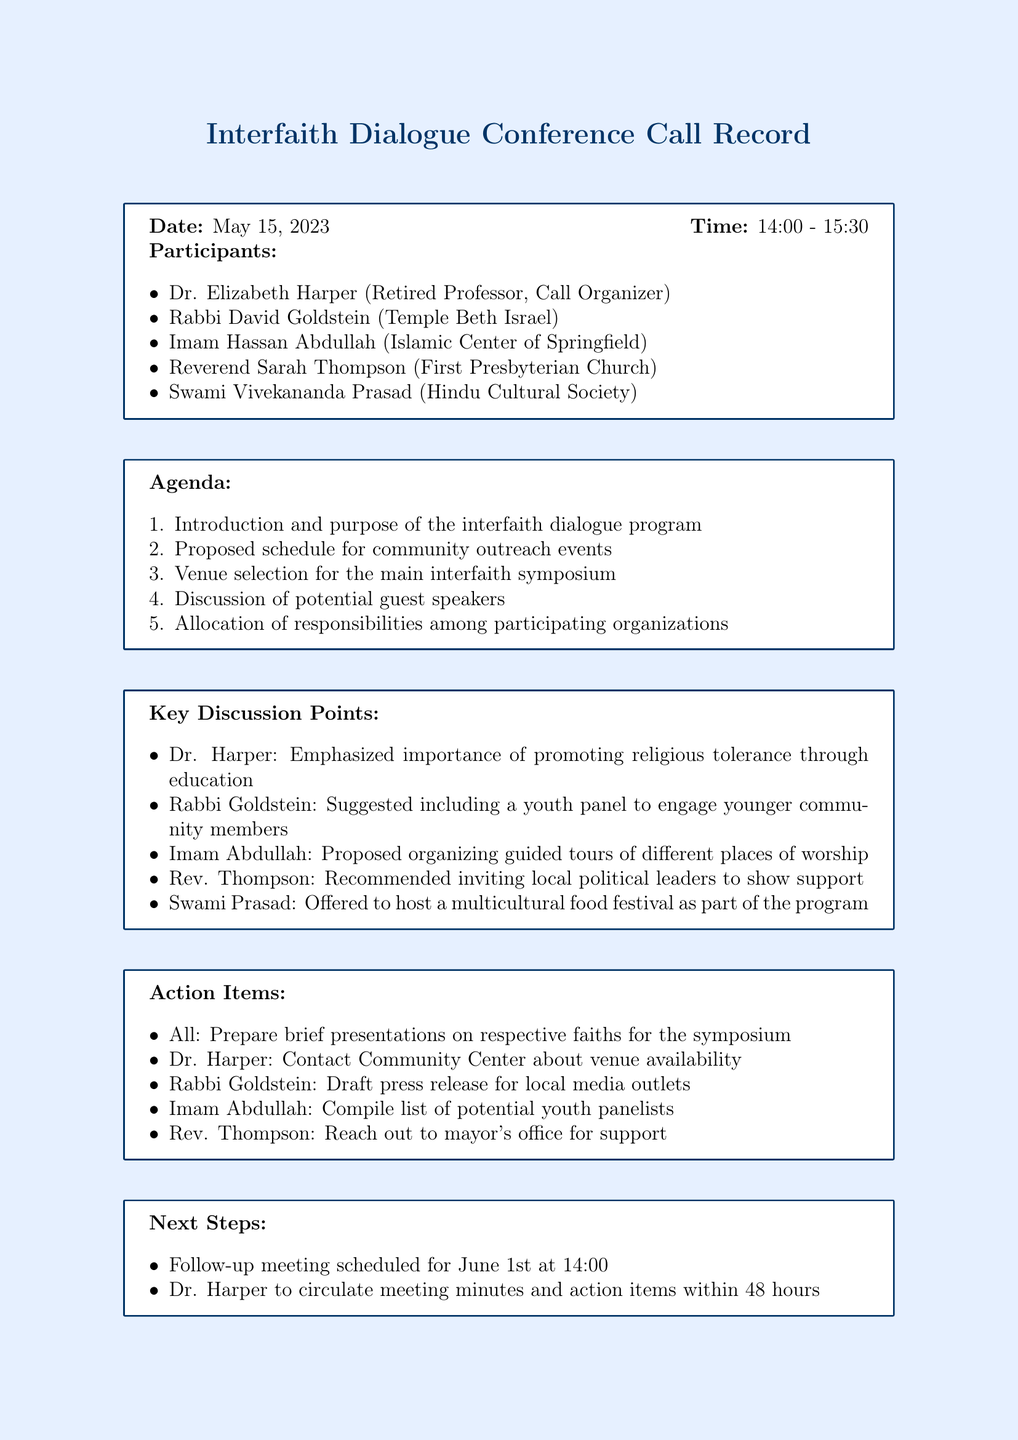What is the date of the conference call? The date of the conference call is explicitly stated in the document as May 15, 2023.
Answer: May 15, 2023 Who organized the call? The document specifies Dr. Elizabeth Harper as the call organizer.
Answer: Dr. Elizabeth Harper What was suggested to engage younger community members? Rabbi Goldstein suggested including a youth panel to engage younger community members.
Answer: Youth panel What is one of the proposed action items? The action items include preparation of brief presentations on respective faiths for the symposium, derived from the document.
Answer: Prepare presentations When is the next follow-up meeting scheduled? The next follow-up meeting is scheduled for June 1st at 14:00, as indicated in the document.
Answer: June 1st at 14:00 Which organization offered to host a multicultural food festival? Swami Vivekananda Prasad from the Hindu Cultural Society offered to host a multicultural food festival.
Answer: Hindu Cultural Society What is the purpose of the conference call mentioned in the agenda? The first agenda item indicates the purpose is the introduction and purpose of the interfaith dialogue program.
Answer: Interfaith dialogue program Who is responsible for reaching out to the mayor's office for support? Reverend Sarah Thompson is responsible for reaching out to the mayor's office for support, according to the action items.
Answer: Reverend Sarah Thompson 